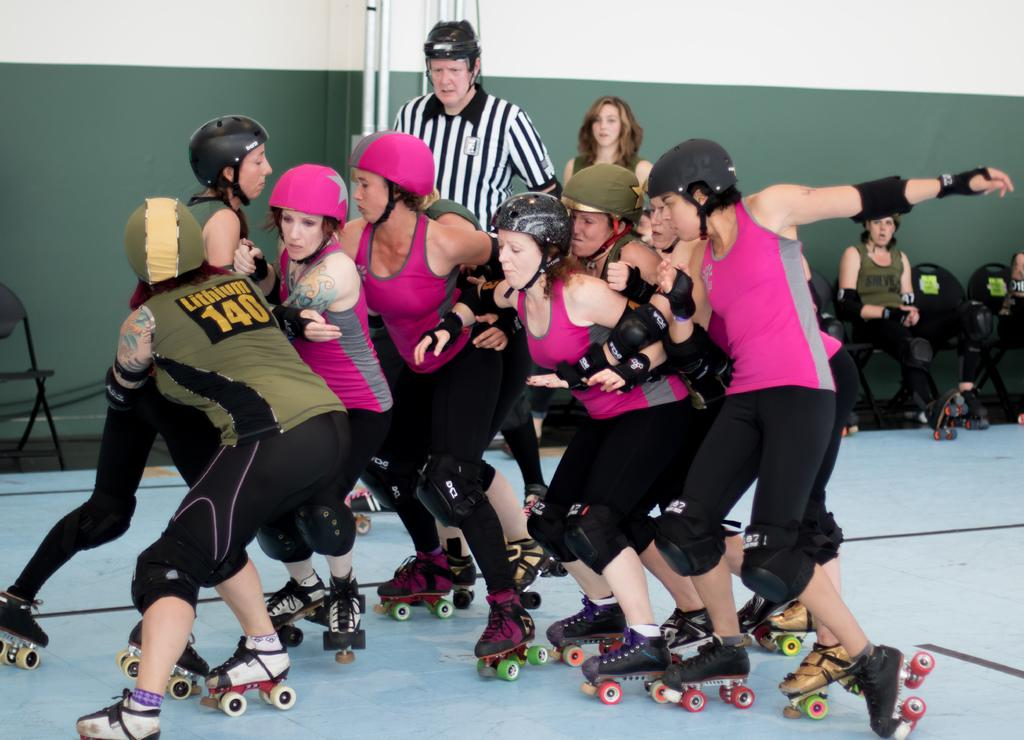Provide a one-sentence caption for the provided image. Women are roller skating in a huddle, one woman is wearing the number 140 on her back. 